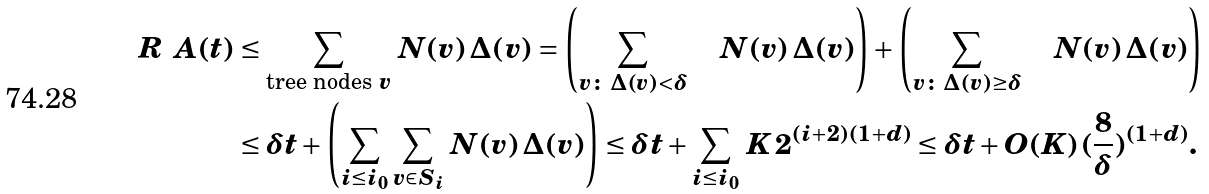<formula> <loc_0><loc_0><loc_500><loc_500>R _ { \ } A ( t ) & \leq \sum _ { \text {tree nodes $v$} } \, N ( v ) \, \Delta ( v ) = \left ( \sum _ { v \colon \, \Delta ( v ) < \delta } \quad N ( v ) \, \Delta ( v ) \right ) + \left ( \sum _ { v \colon \, \Delta ( v ) \geq \delta } \quad N ( v ) \, \Delta ( v ) \right ) \\ & \leq \delta t + \left ( \sum _ { i \leq i _ { 0 } } \sum _ { v \in S _ { i } } \, N ( v ) \, \Delta ( v ) \right ) \leq \delta t + \sum _ { i \leq i _ { 0 } } \, K \, 2 ^ { ( i + 2 ) ( 1 + d ) } \leq \delta t + O ( K ) \, ( \frac { 8 } { \delta } ) ^ { ( 1 + d ) } .</formula> 